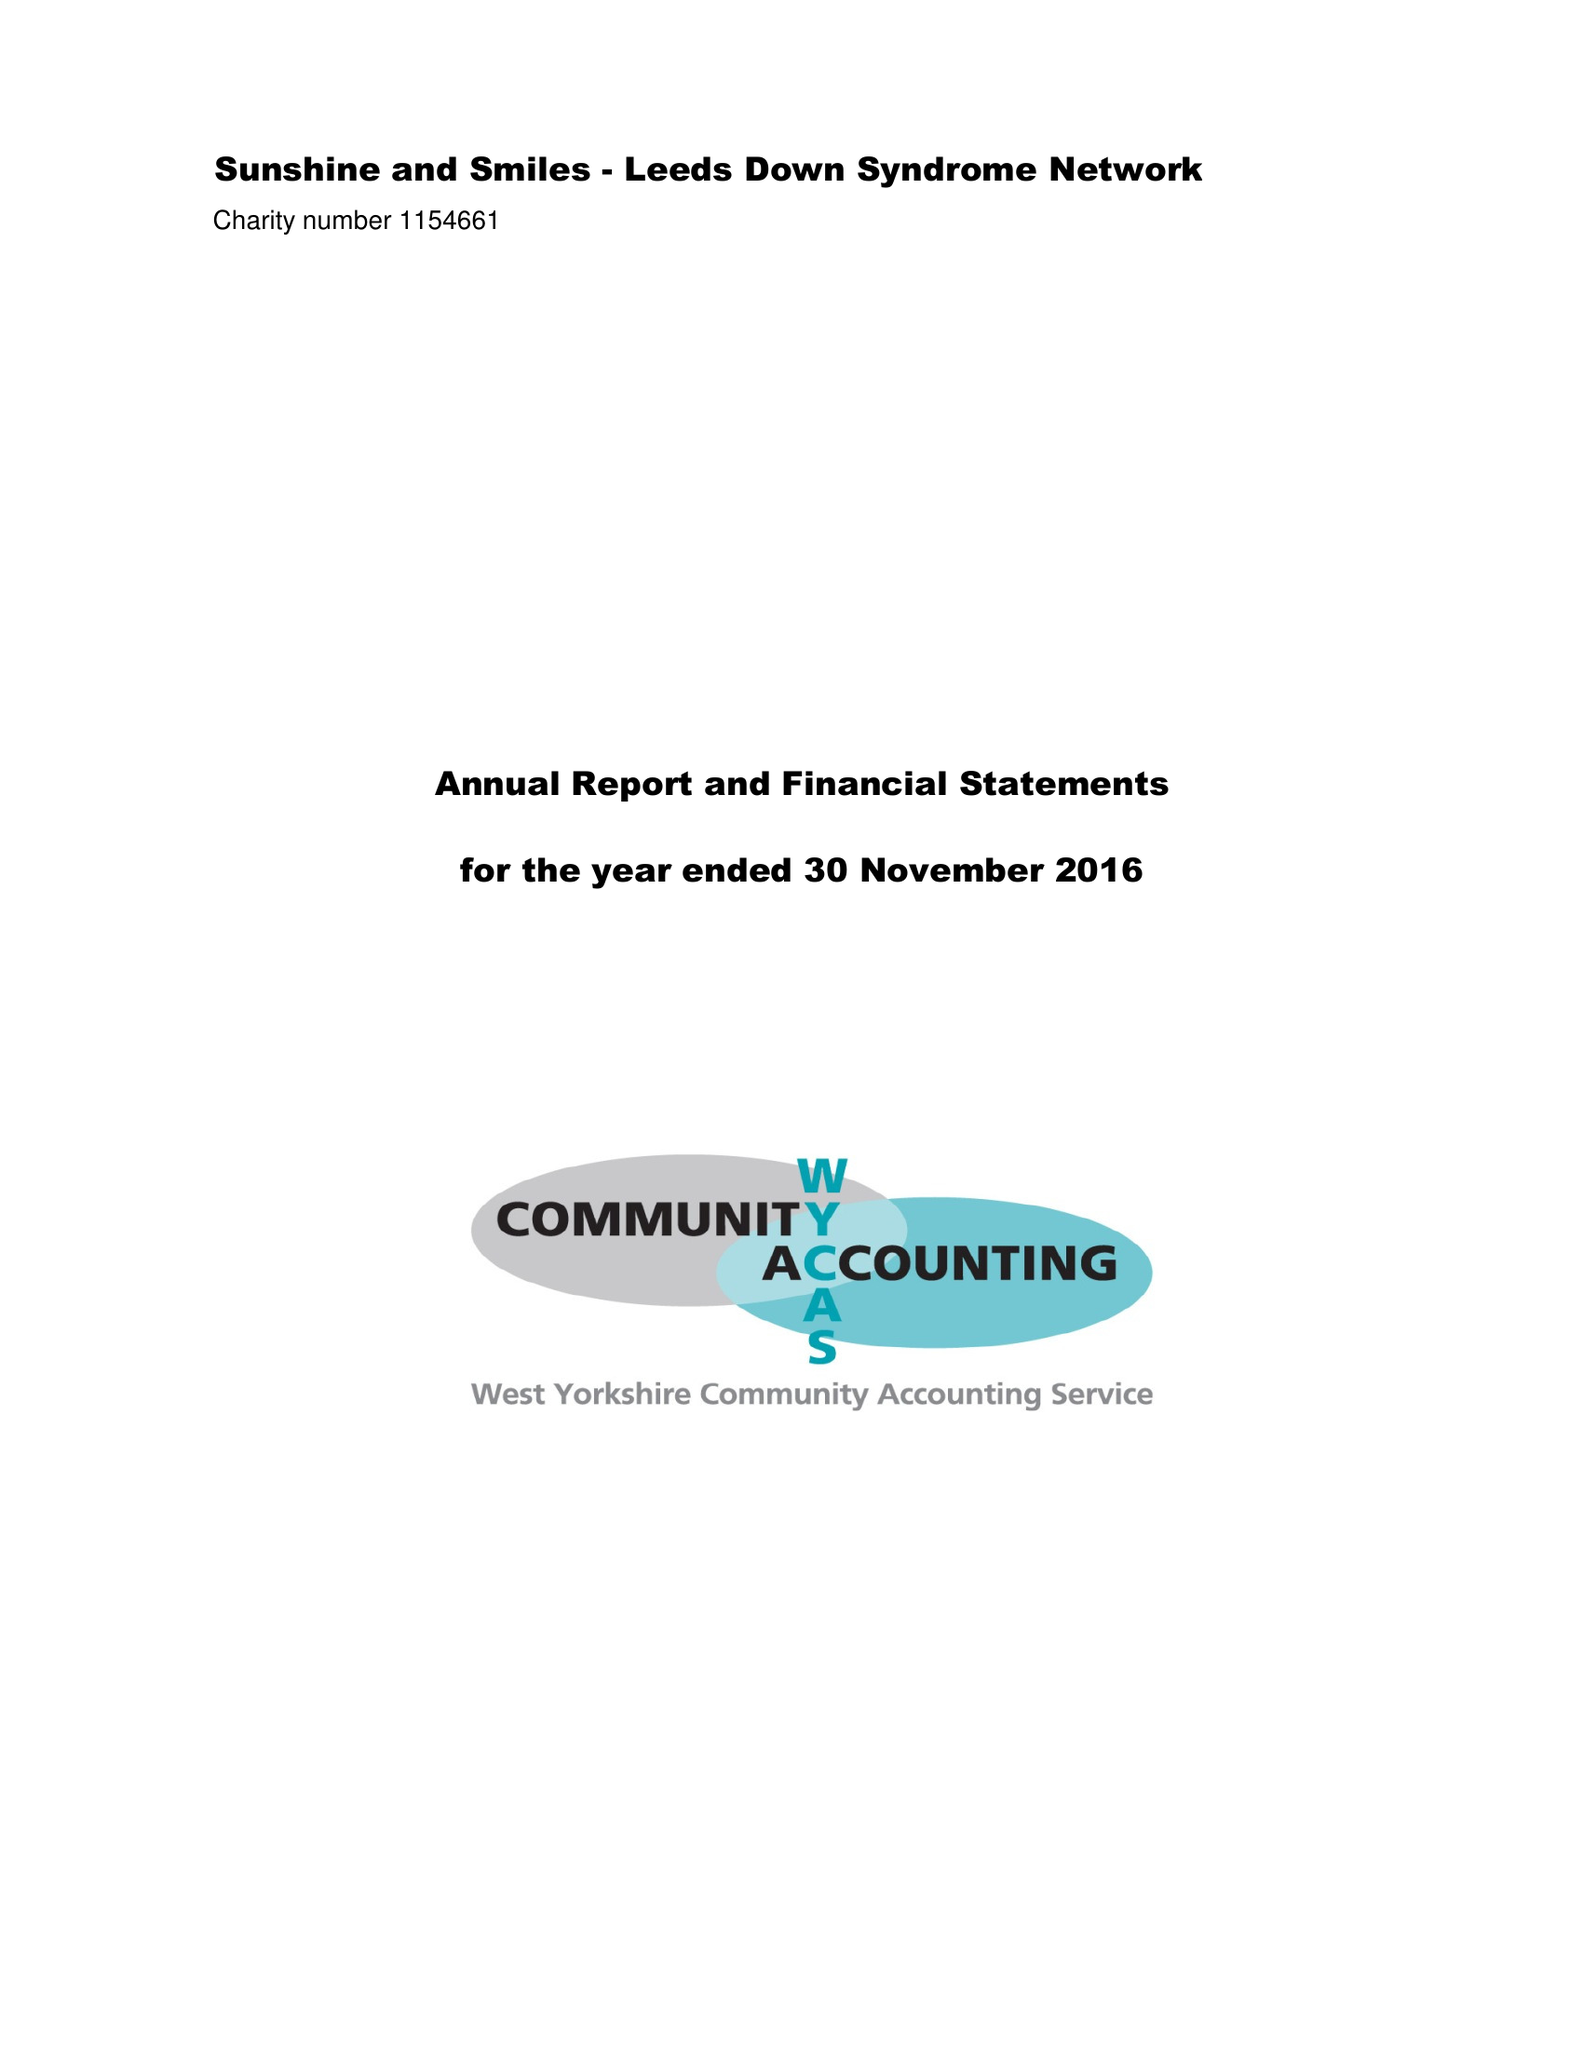What is the value for the address__street_line?
Answer the question using a single word or phrase. 3 DRUMMOND ROAD 